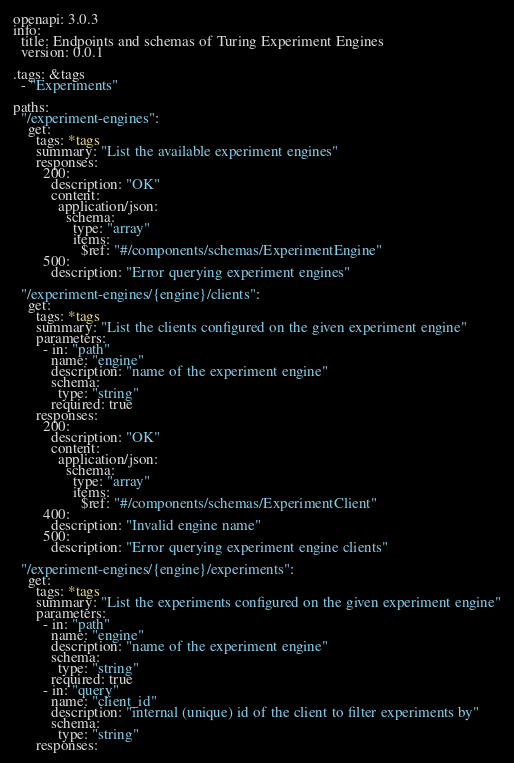Convert code to text. <code><loc_0><loc_0><loc_500><loc_500><_YAML_>openapi: 3.0.3
info:
  title: Endpoints and schemas of Turing Experiment Engines
  version: 0.0.1

.tags: &tags
  - "Experiments"

paths:
  "/experiment-engines":
    get:
      tags: *tags
      summary: "List the available experiment engines"
      responses:
        200:
          description: "OK"
          content:
            application/json:
              schema:
                type: "array"
                items:
                  $ref: "#/components/schemas/ExperimentEngine"
        500:
          description: "Error querying experiment engines"

  "/experiment-engines/{engine}/clients":
    get:
      tags: *tags
      summary: "List the clients configured on the given experiment engine"
      parameters:
        - in: "path"
          name: "engine"
          description: "name of the experiment engine"
          schema:
            type: "string"
          required: true
      responses:
        200:
          description: "OK"
          content:
            application/json:
              schema:
                type: "array"
                items:
                  $ref: "#/components/schemas/ExperimentClient"
        400:
          description: "Invalid engine name"
        500:
          description: "Error querying experiment engine clients"

  "/experiment-engines/{engine}/experiments":
    get:
      tags: *tags
      summary: "List the experiments configured on the given experiment engine"
      parameters:
        - in: "path"
          name: "engine"
          description: "name of the experiment engine"
          schema:
            type: "string"
          required: true
        - in: "query"
          name: "client_id"
          description: "internal (unique) id of the client to filter experiments by"
          schema:
            type: "string"
      responses:</code> 